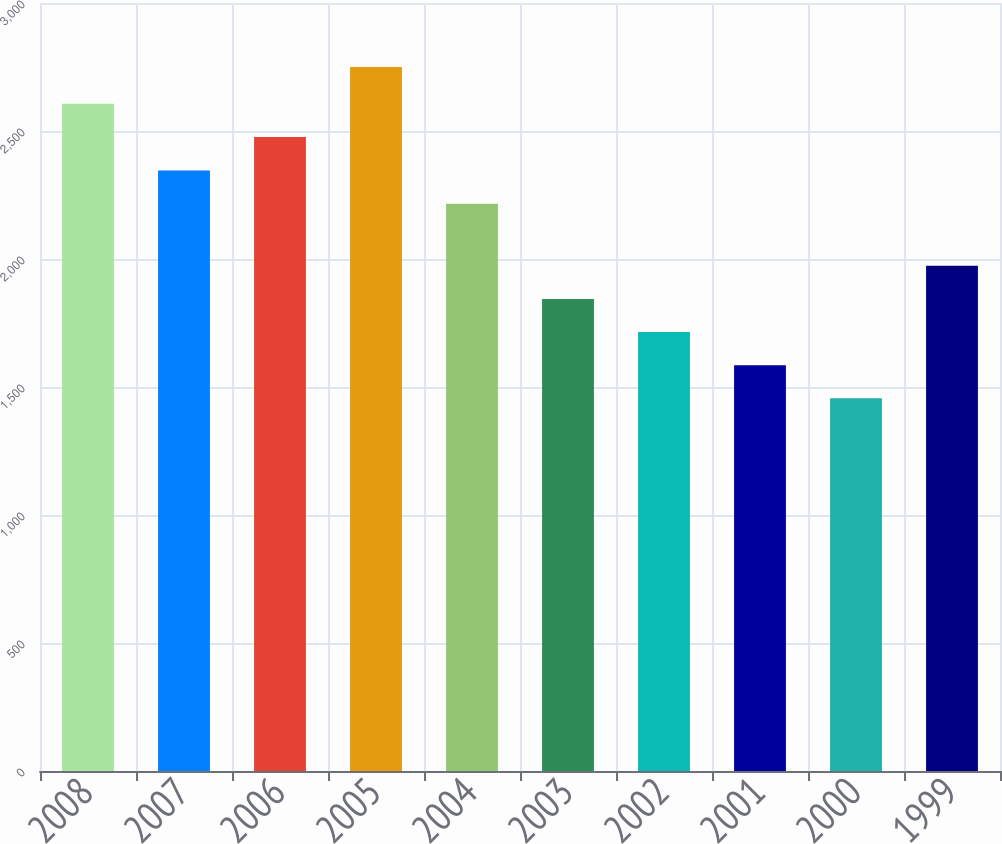<chart> <loc_0><loc_0><loc_500><loc_500><bar_chart><fcel>2008<fcel>2007<fcel>2006<fcel>2005<fcel>2004<fcel>2003<fcel>2002<fcel>2001<fcel>2000<fcel>1999<nl><fcel>2606.4<fcel>2345.4<fcel>2477<fcel>2750<fcel>2216<fcel>1844.2<fcel>1714.8<fcel>1585.4<fcel>1456<fcel>1973.6<nl></chart> 